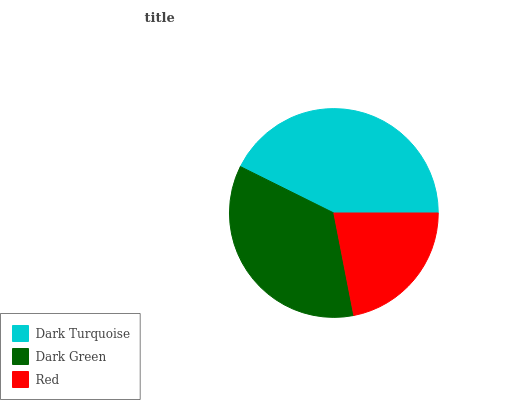Is Red the minimum?
Answer yes or no. Yes. Is Dark Turquoise the maximum?
Answer yes or no. Yes. Is Dark Green the minimum?
Answer yes or no. No. Is Dark Green the maximum?
Answer yes or no. No. Is Dark Turquoise greater than Dark Green?
Answer yes or no. Yes. Is Dark Green less than Dark Turquoise?
Answer yes or no. Yes. Is Dark Green greater than Dark Turquoise?
Answer yes or no. No. Is Dark Turquoise less than Dark Green?
Answer yes or no. No. Is Dark Green the high median?
Answer yes or no. Yes. Is Dark Green the low median?
Answer yes or no. Yes. Is Dark Turquoise the high median?
Answer yes or no. No. Is Dark Turquoise the low median?
Answer yes or no. No. 